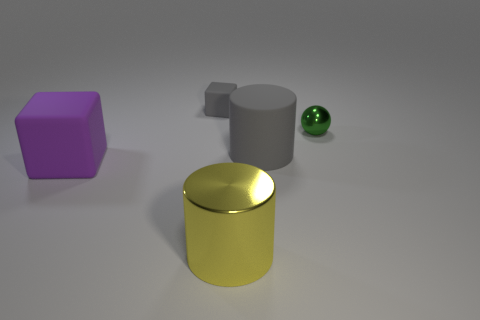Add 1 gray things. How many objects exist? 6 Subtract all blocks. How many objects are left? 3 Subtract 0 brown cylinders. How many objects are left? 5 Subtract all yellow metallic cylinders. Subtract all large gray matte cylinders. How many objects are left? 3 Add 4 small matte objects. How many small matte objects are left? 5 Add 1 small gray matte cubes. How many small gray matte cubes exist? 2 